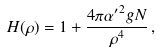<formula> <loc_0><loc_0><loc_500><loc_500>H ( \rho ) = 1 + { \frac { 4 \pi { \alpha ^ { \prime } } ^ { 2 } g N } { \rho ^ { 4 } } } \, ,</formula> 